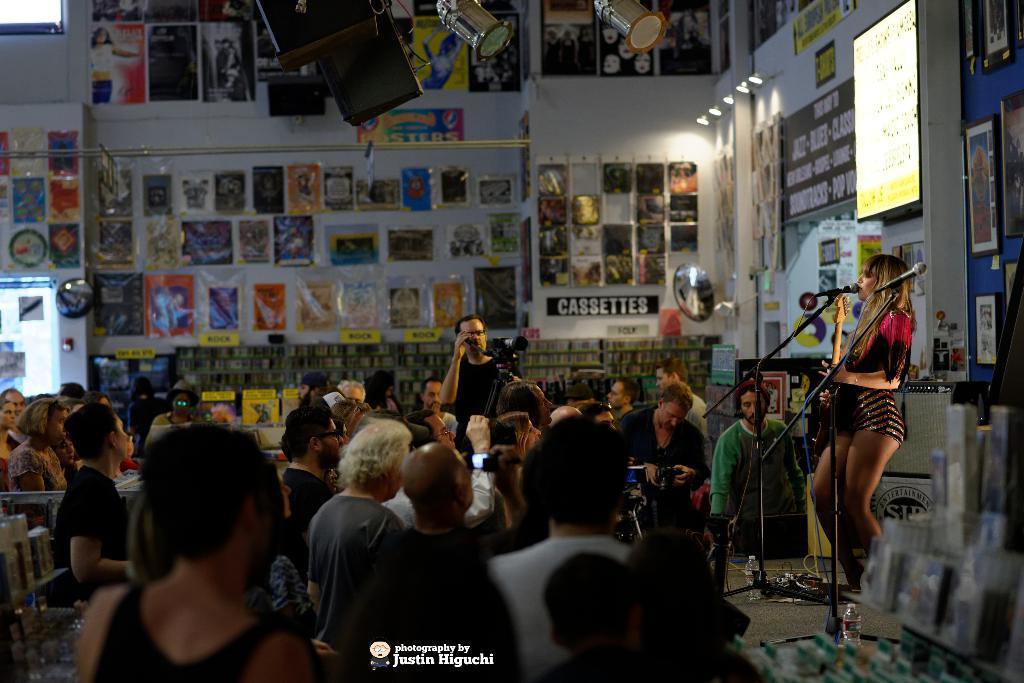In one or two sentences, can you explain what this image depicts? On the right side of the image we can see a woman standing on the dais at the mic. At the bottom of the image we can see persons, tables and chairs. In the background we can see photo frames, lights, speakers and wall. 